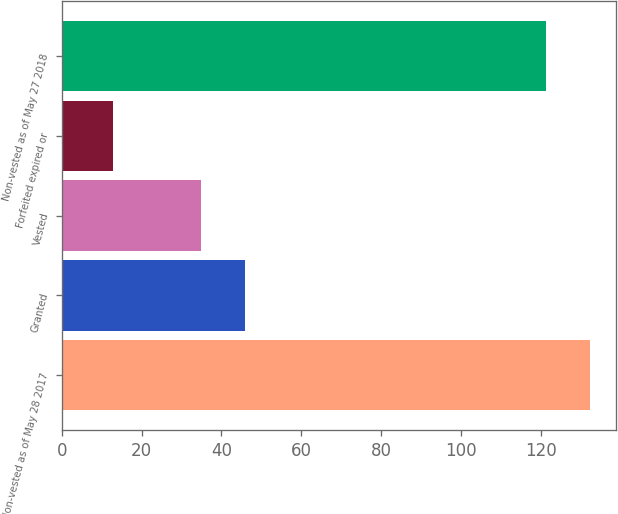Convert chart to OTSL. <chart><loc_0><loc_0><loc_500><loc_500><bar_chart><fcel>Non-vested as of May 28 2017<fcel>Granted<fcel>Vested<fcel>Forfeited expired or<fcel>Non-vested as of May 27 2018<nl><fcel>132.35<fcel>45.85<fcel>34.8<fcel>12.8<fcel>121.3<nl></chart> 